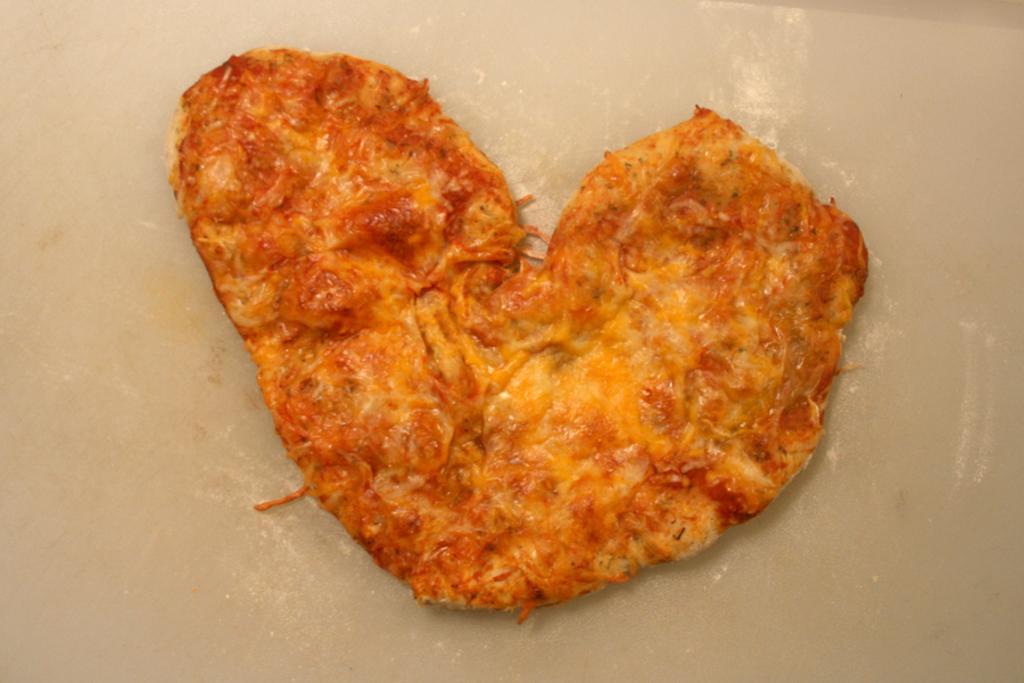Can you describe this image briefly? There is a food item which is in heart shape. 